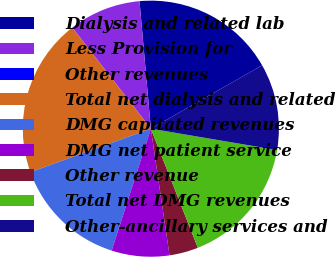Convert chart to OTSL. <chart><loc_0><loc_0><loc_500><loc_500><pie_chart><fcel>Dialysis and related lab<fcel>Less Provision for<fcel>Other revenues<fcel>Total net dialysis and related<fcel>DMG capitated revenues<fcel>DMG net patient service<fcel>Other revenue<fcel>Total net DMG revenues<fcel>Other-ancillary services and<nl><fcel>18.17%<fcel>9.09%<fcel>0.02%<fcel>19.99%<fcel>14.54%<fcel>7.28%<fcel>3.65%<fcel>16.35%<fcel>10.91%<nl></chart> 